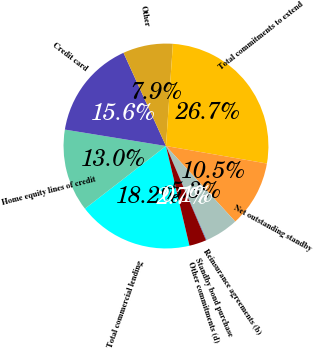Convert chart to OTSL. <chart><loc_0><loc_0><loc_500><loc_500><pie_chart><fcel>Total commercial lending<fcel>Home equity lines of credit<fcel>Credit card<fcel>Other<fcel>Total commitments to extend<fcel>Net outstanding standby<fcel>Reinsurance agreements (b)<fcel>Standby bond purchase<fcel>Other commitments (d)<nl><fcel>18.21%<fcel>13.04%<fcel>15.63%<fcel>7.88%<fcel>26.66%<fcel>10.46%<fcel>5.29%<fcel>0.13%<fcel>2.71%<nl></chart> 